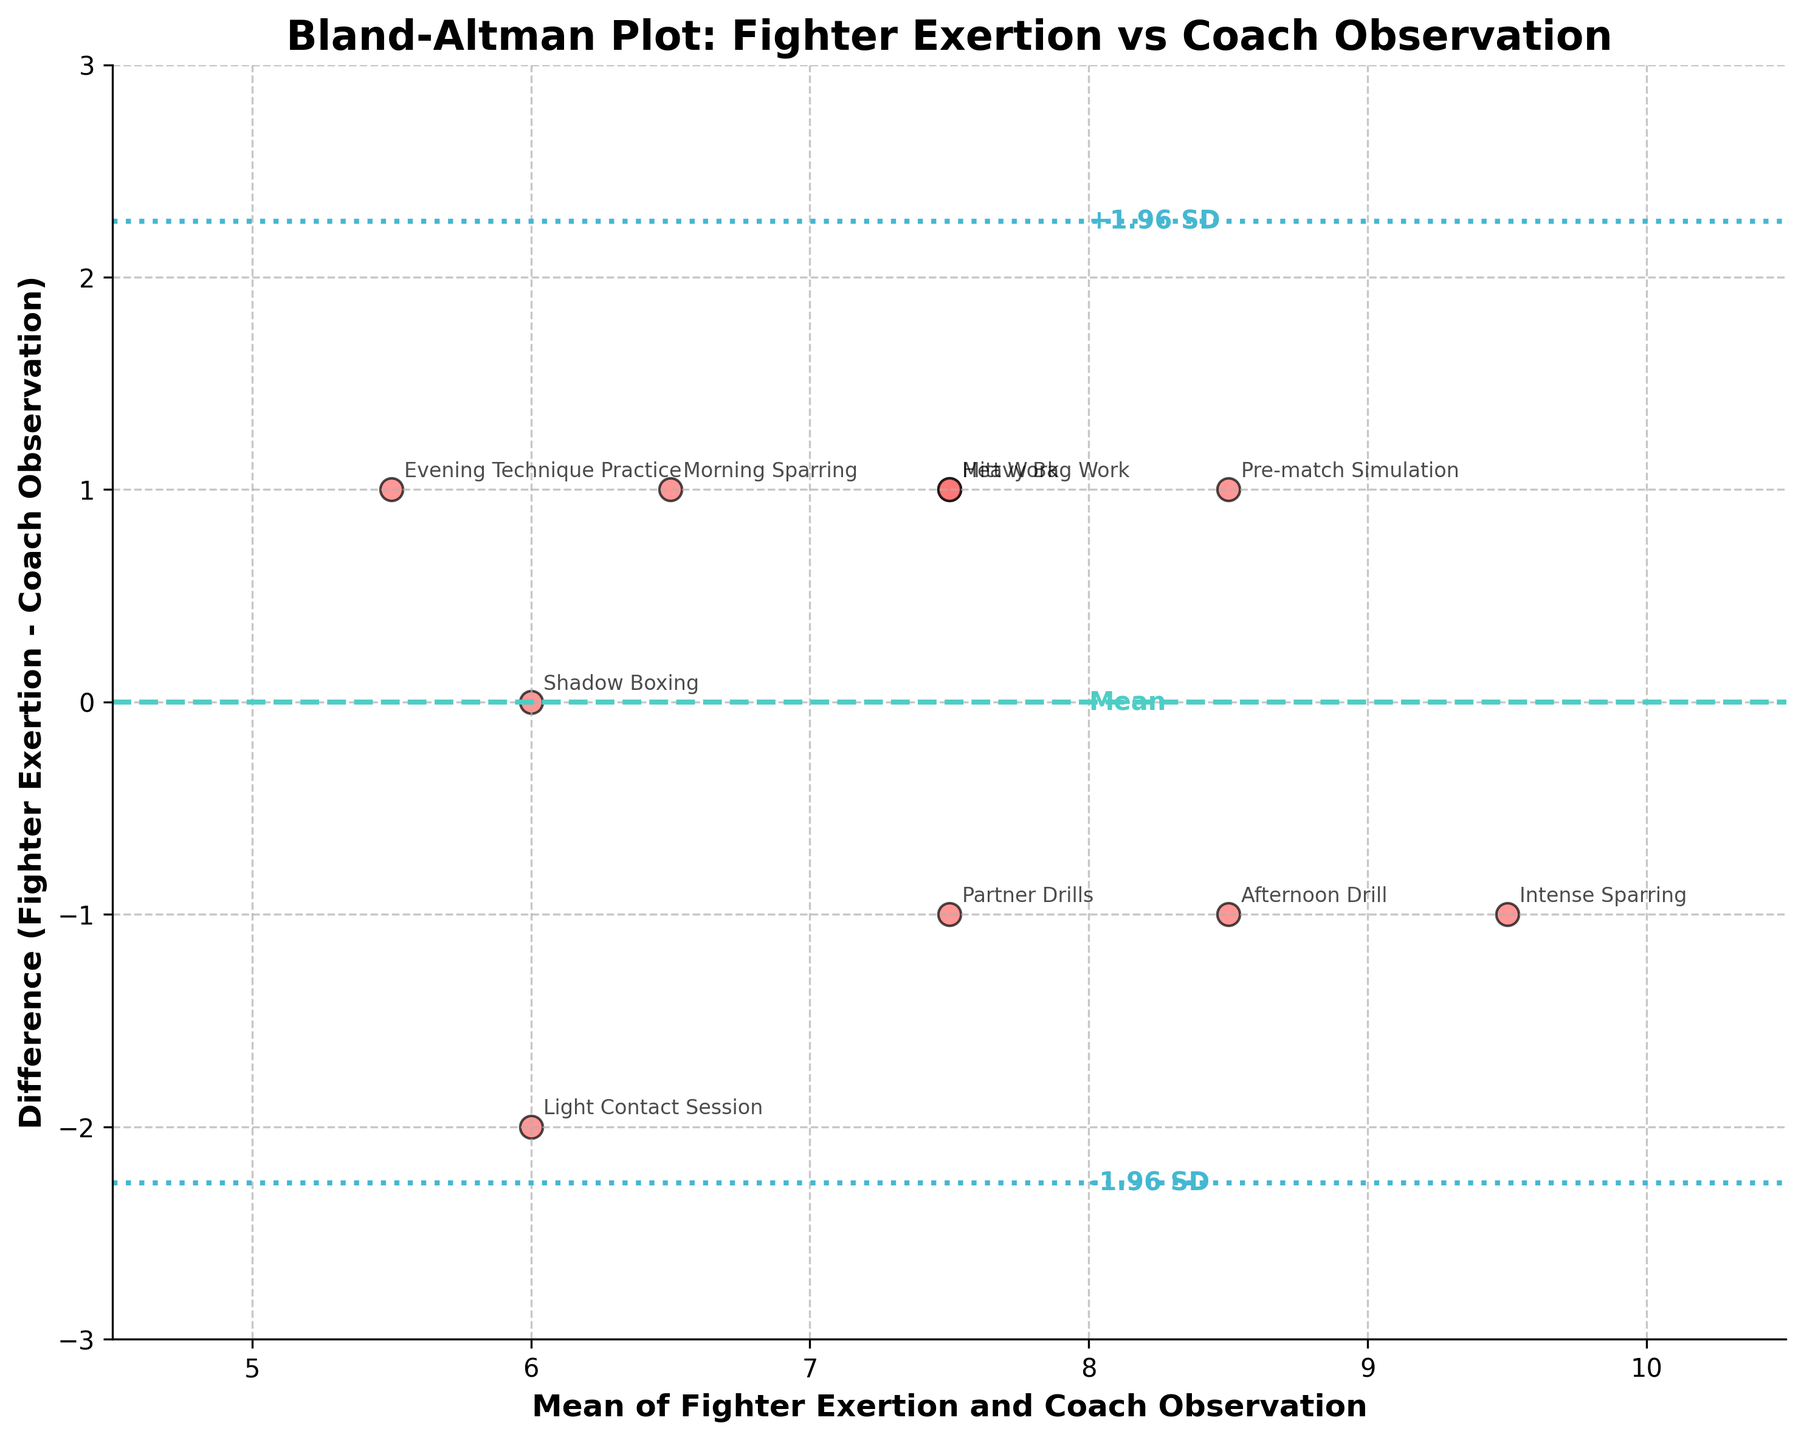What is the title of the plot? The title is usually located at the top of the plot and in this case, it is "Bland-Altman Plot: Fighter Exertion vs Coach Observation".
Answer: Bland-Altman Plot: Fighter Exertion vs Coach Observation How many data points are there on the plot? Each sparring session has a corresponding data point. Based on the given data and annotations on the plot, there are 10 data points.
Answer: 10 What does the y-axis represent in this plot? The y-axis of a Bland-Altman plot shows the difference between the two sets of measurements, in this case, the difference between Fighter Exertion and Coach Observation.
Answer: Difference (Fighter Exertion - Coach Observation) What is the mean difference between Fighter Exertion and Coach Observation? The horizontal dashed line represents the mean difference. Based on the figure this line is set at 0.4.
Answer: 0.4 What do the dotted lines show in the plot? The dotted lines typically represent the limits of agreement, which are calculated as the mean difference plus or minus 1.96 times the standard deviation. Based on this plot, they are located at -1.803 and 2.603.
Answer: Limits of agreement Which session has the largest positive difference between Fighter Exertion and Coach Observation? To determine this, look for the data point with the highest value on the y-axis. The "Light Contact Session" has the largest positive difference (2).
Answer: Light Contact Session What does the x-axis represent in this plot? The x-axis of a Bland-Altman plot shows the mean of the two sets of measurements, in this case, the mean of Fighter Exertion and Coach Observation.
Answer: Mean of Fighter Exertion and Coach Observation Which session is closest to the mean difference line? The data point closest to the mean difference line (0.4) can be observed. "Heavy Bag Work" lies closest to this line, with a difference of 1.
Answer: Heavy Bag Work What are the values of the limits of agreement on the plot? The limits of agreement are shown as dotted lines on the plot. They are at approximately -1.803 and 2.603.
Answer: -1.803 and 2.603 